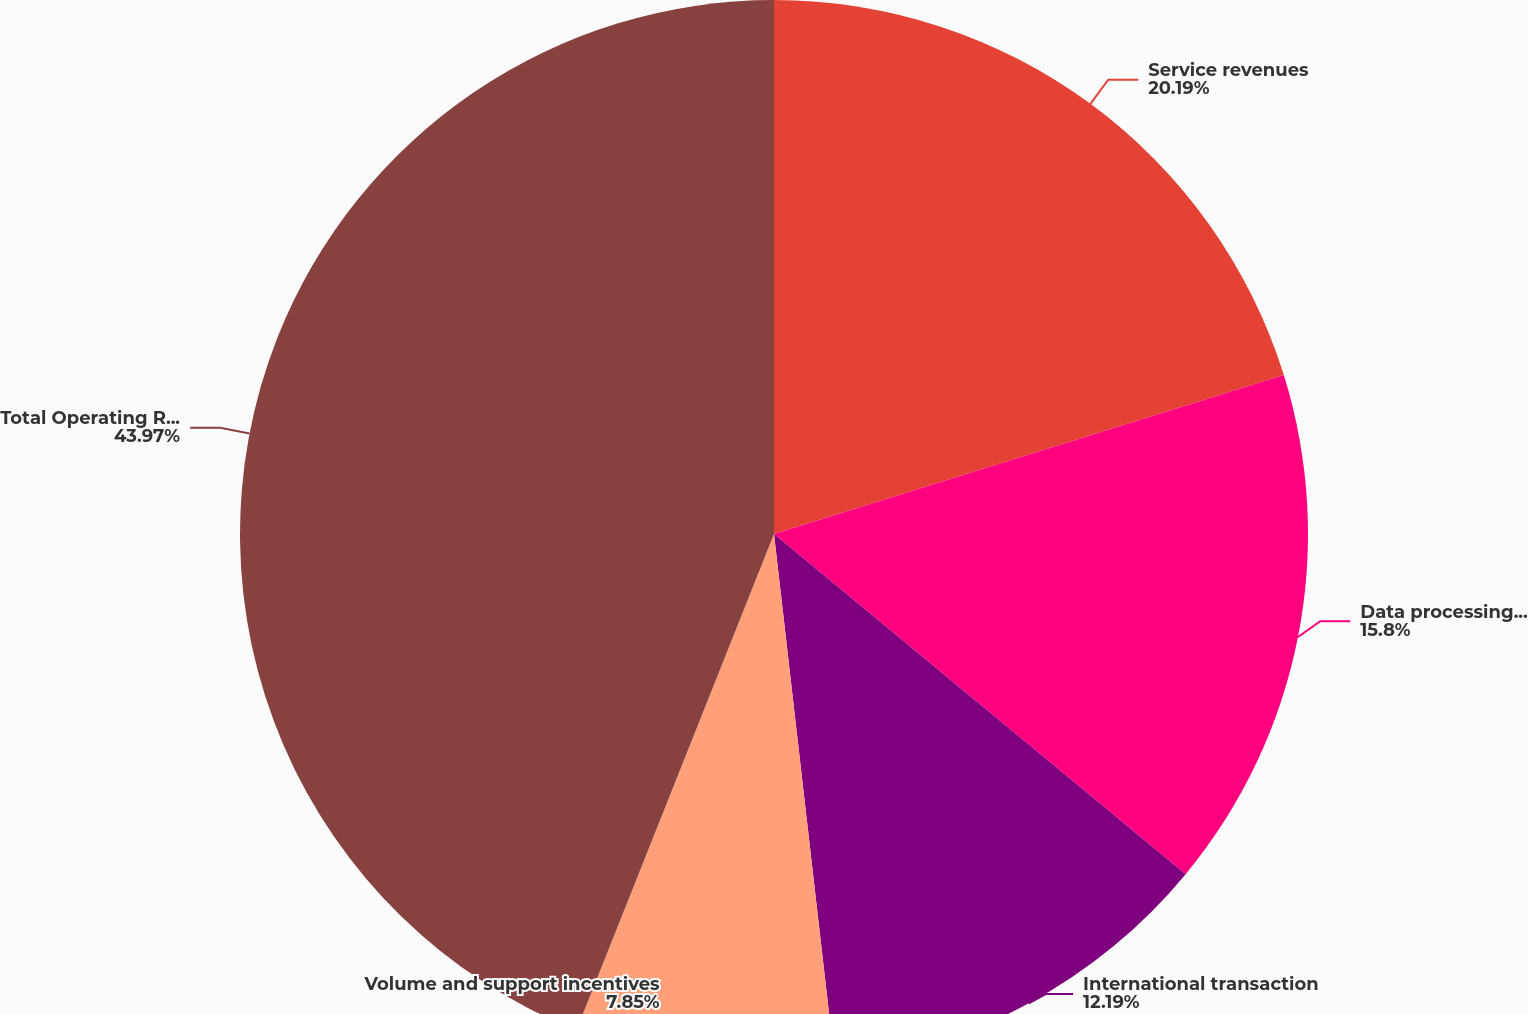Convert chart. <chart><loc_0><loc_0><loc_500><loc_500><pie_chart><fcel>Service revenues<fcel>Data processing revenues<fcel>International transaction<fcel>Volume and support incentives<fcel>Total Operating Revenues<nl><fcel>20.19%<fcel>15.8%<fcel>12.19%<fcel>7.85%<fcel>43.97%<nl></chart> 